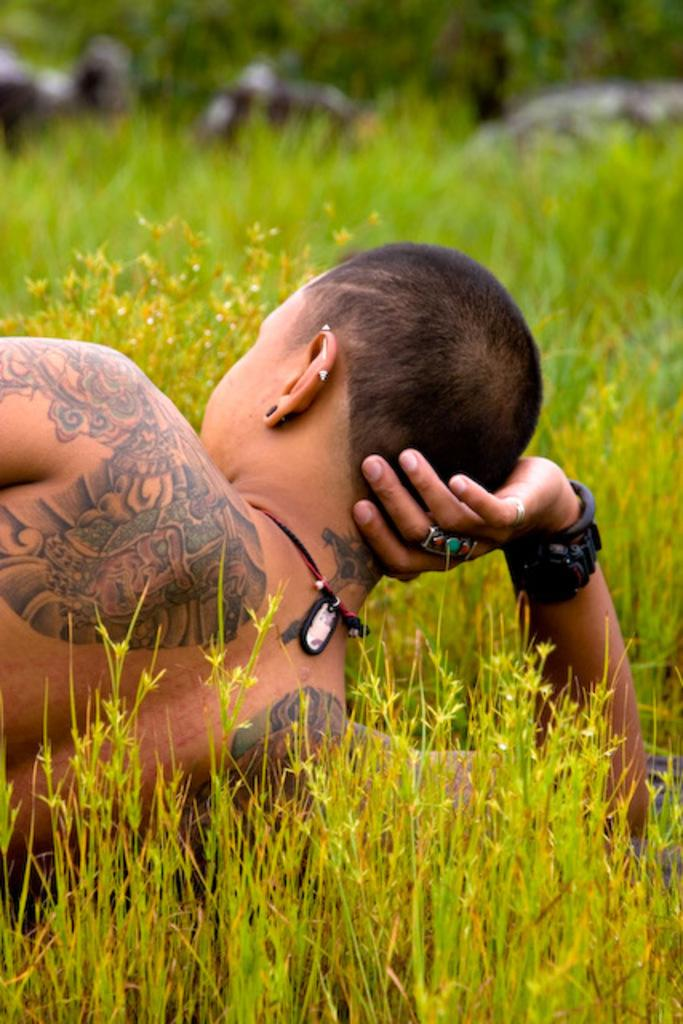Who is the main subject in the image? There is a man in the image. What distinguishing feature can be seen on the man's body? The man has a tattoo on his body. What type of vegetation is visible at the bottom of the image? There is green grass at the bottom of the image. What can be seen in the distance in the image? There are trees in the background of the image. How would you describe the background of the image? The background is blurred. What type of question is being asked in the image? There is no question being asked in the image; it is a photograph of a man with a tattoo. Can you see any honey dripping from the trees in the background? There is no honey present in the image; it features a man with a tattoo and a blurred background with trees. 